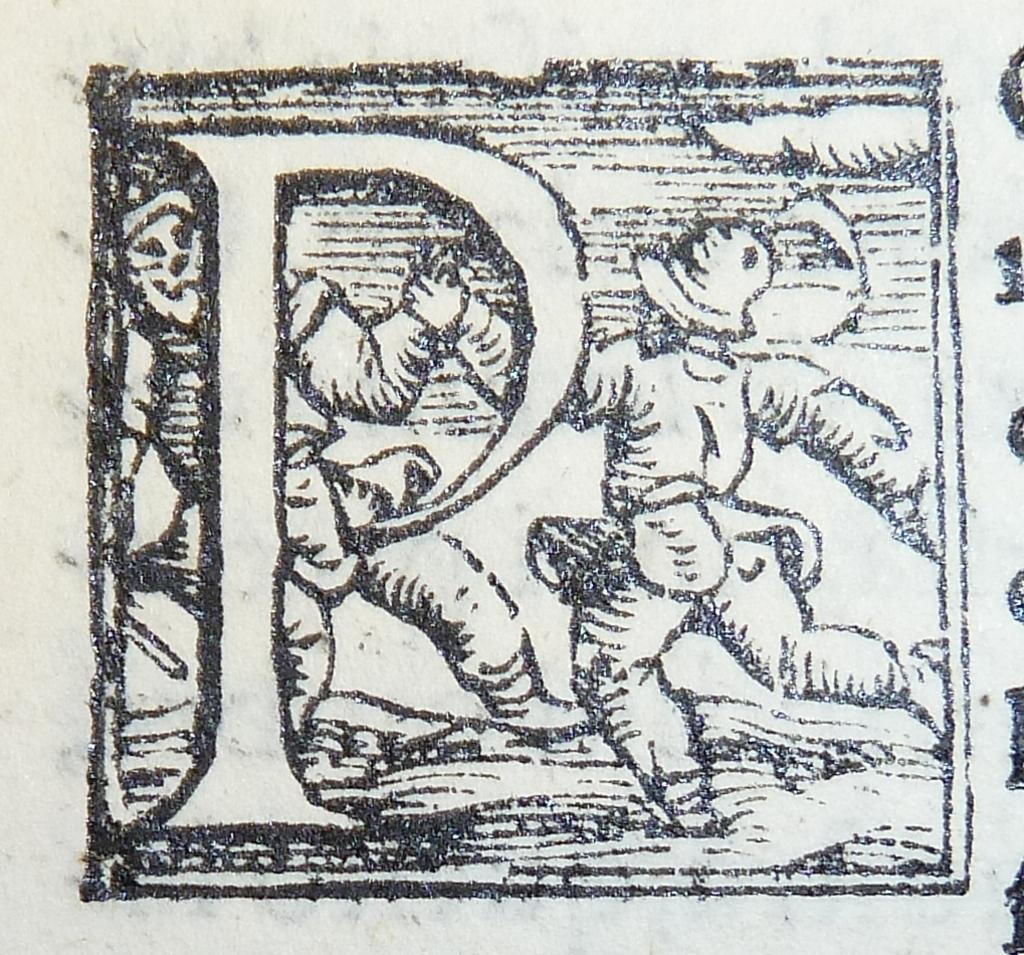What is present in the image that can be written or printed on? There is a paper in the image that can be written or printed on. What can be seen on the paper in the image? The paper has a print on it, which contains images. What is the minister's income mentioned in the image? There is no mention of a minister or income in the image; it only contains a paper with a print containing images. 